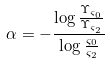<formula> <loc_0><loc_0><loc_500><loc_500>\alpha = - \frac { \log \frac { \Upsilon _ { \varsigma _ { 0 } } } { \Upsilon _ { \varsigma _ { 2 } } } } { \log \frac { \varsigma _ { 0 } } { \varsigma _ { 2 } } }</formula> 